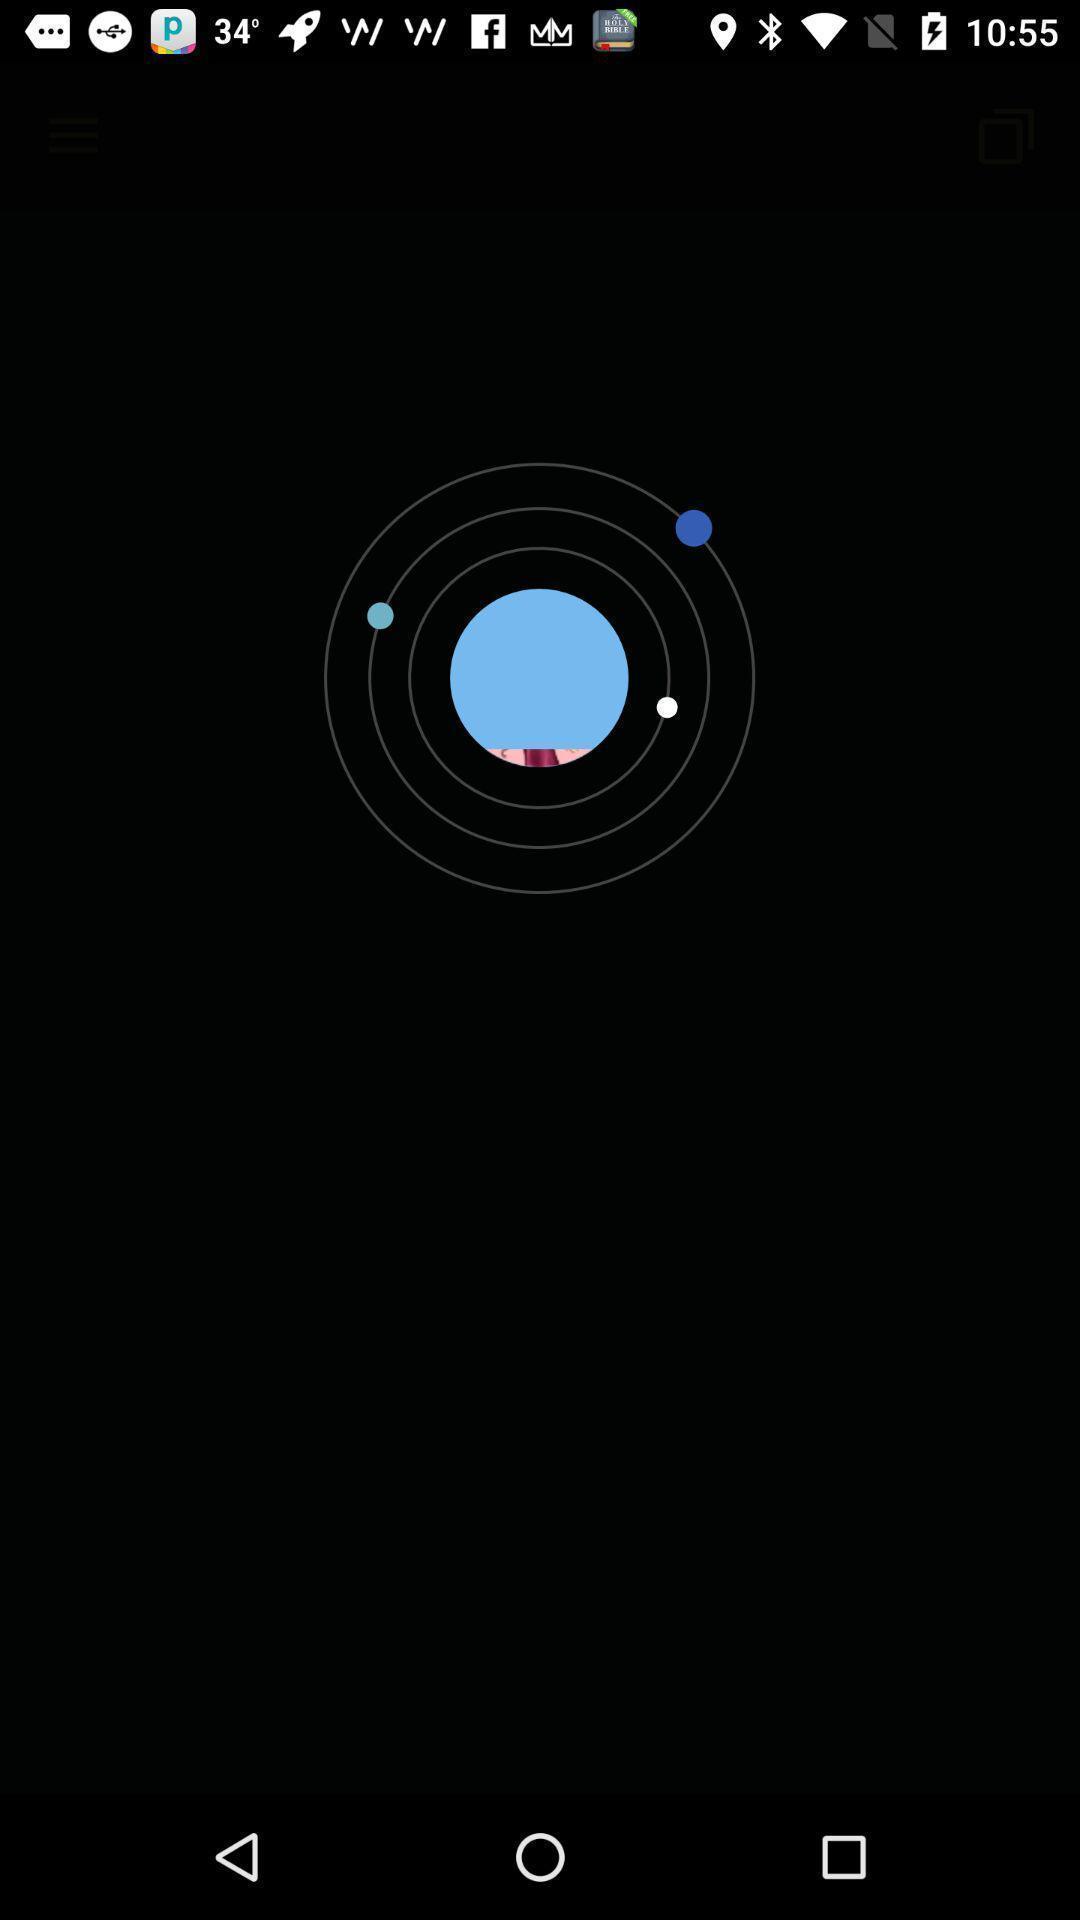Please provide a description for this image. Unknown page of a chatting app. 